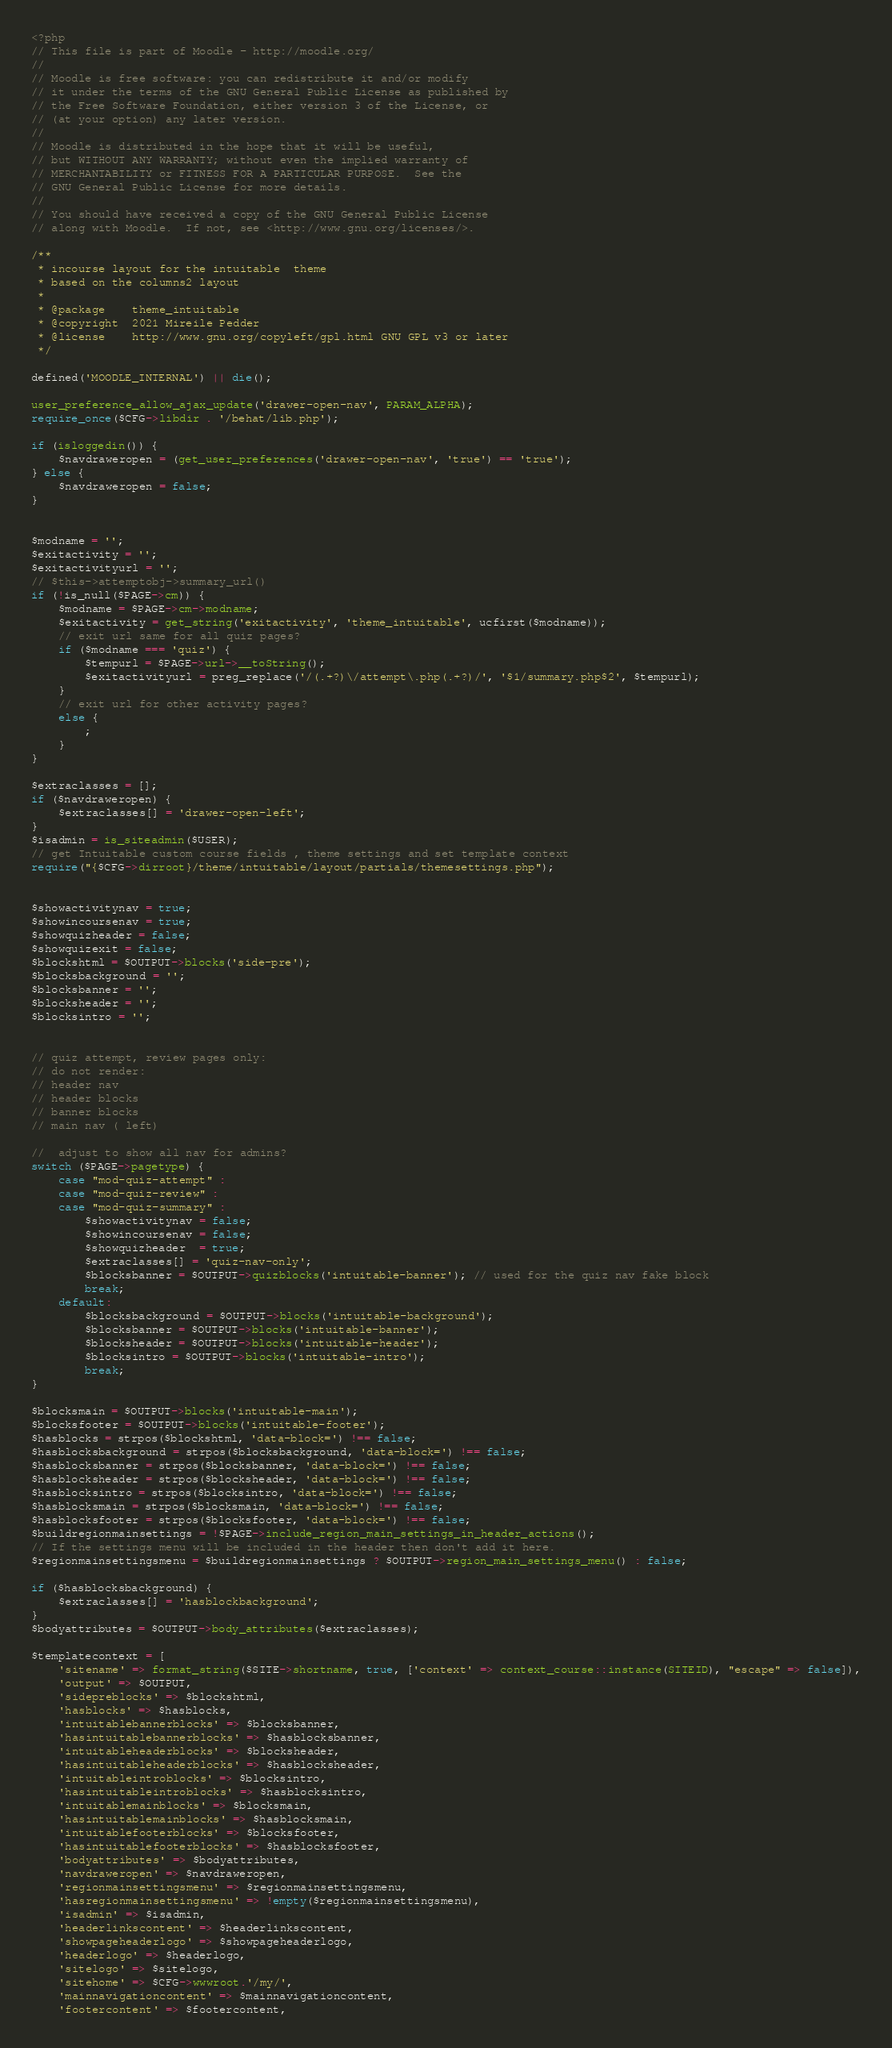Convert code to text. <code><loc_0><loc_0><loc_500><loc_500><_PHP_><?php
// This file is part of Moodle - http://moodle.org/
//
// Moodle is free software: you can redistribute it and/or modify
// it under the terms of the GNU General Public License as published by
// the Free Software Foundation, either version 3 of the License, or
// (at your option) any later version.
//
// Moodle is distributed in the hope that it will be useful,
// but WITHOUT ANY WARRANTY; without even the implied warranty of
// MERCHANTABILITY or FITNESS FOR A PARTICULAR PURPOSE.  See the
// GNU General Public License for more details.
//
// You should have received a copy of the GNU General Public License
// along with Moodle.  If not, see <http://www.gnu.org/licenses/>.

/**
 * incourse layout for the intuitable  theme
 * based on the columns2 layout 
 *
 * @package    theme_intuitable
 * @copyright  2021 Mireile Pedder
 * @license    http://www.gnu.org/copyleft/gpl.html GNU GPL v3 or later
 */

defined('MOODLE_INTERNAL') || die();

user_preference_allow_ajax_update('drawer-open-nav', PARAM_ALPHA);
require_once($CFG->libdir . '/behat/lib.php');

if (isloggedin()) {
    $navdraweropen = (get_user_preferences('drawer-open-nav', 'true') == 'true');
} else {
    $navdraweropen = false;
}


$modname = '';
$exitactivity = '';
$exitactivityurl = '';
// $this->attemptobj->summary_url()
if (!is_null($PAGE->cm)) {
    $modname = $PAGE->cm->modname;
    $exitactivity = get_string('exitactivity', 'theme_intuitable', ucfirst($modname));
    // exit url same for all quiz pages?
    if ($modname === 'quiz') {
        $tempurl = $PAGE->url->__toString();
        $exitactivityurl = preg_replace('/(.+?)\/attempt\.php(.+?)/', '$1/summary.php$2', $tempurl);
    }
    // exit url for other activity pages?
    else {
        ;
    }
}

$extraclasses = [];
if ($navdraweropen) {
    $extraclasses[] = 'drawer-open-left';
}
$isadmin = is_siteadmin($USER);
// get Intuitable custom course fields , theme settings and set template context
require("{$CFG->dirroot}/theme/intuitable/layout/partials/themesettings.php"); 


$showactivitynav = true;
$showincoursenav = true;
$showquizheader = false;
$showquizexit = false;
$blockshtml = $OUTPUT->blocks('side-pre');
$blocksbackground = '';
$blocksbanner = '';
$blocksheader = '';
$blocksintro = '';


// quiz attempt, review pages only:
// do not render:
// header nav
// header blocks
// banner blocks
// main nav ( left)

//  adjust to show all nav for admins?
switch ($PAGE->pagetype) {
    case "mod-quiz-attempt" :
    case "mod-quiz-review" : 
    case "mod-quiz-summary" : 
        $showactivitynav = false;
        $showincoursenav = false;
        $showquizheader  = true;
        $extraclasses[] = 'quiz-nav-only';
        $blocksbanner = $OUTPUT->quizblocks('intuitable-banner'); // used for the quiz nav fake block
        break;
    default: 
        $blocksbackground = $OUTPUT->blocks('intuitable-background');
        $blocksbanner = $OUTPUT->blocks('intuitable-banner');
        $blocksheader = $OUTPUT->blocks('intuitable-header');    
        $blocksintro = $OUTPUT->blocks('intuitable-intro');
        break;
}

$blocksmain = $OUTPUT->blocks('intuitable-main');
$blocksfooter = $OUTPUT->blocks('intuitable-footer');
$hasblocks = strpos($blockshtml, 'data-block=') !== false;
$hasblocksbackground = strpos($blocksbackground, 'data-block=') !== false;
$hasblocksbanner = strpos($blocksbanner, 'data-block=') !== false;
$hasblocksheader = strpos($blocksheader, 'data-block=') !== false;
$hasblocksintro = strpos($blocksintro, 'data-block=') !== false;
$hasblocksmain = strpos($blocksmain, 'data-block=') !== false;
$hasblocksfooter = strpos($blocksfooter, 'data-block=') !== false;
$buildregionmainsettings = !$PAGE->include_region_main_settings_in_header_actions();
// If the settings menu will be included in the header then don't add it here.
$regionmainsettingsmenu = $buildregionmainsettings ? $OUTPUT->region_main_settings_menu() : false;

if ($hasblocksbackground) {
    $extraclasses[] = 'hasblockbackground';
}
$bodyattributes = $OUTPUT->body_attributes($extraclasses);

$templatecontext = [
    'sitename' => format_string($SITE->shortname, true, ['context' => context_course::instance(SITEID), "escape" => false]),
    'output' => $OUTPUT,
    'sidepreblocks' => $blockshtml,
    'hasblocks' => $hasblocks,
    'intuitablebannerblocks' => $blocksbanner,
    'hasintuitablebannerblocks' => $hasblocksbanner,
    'intuitableheaderblocks' => $blocksheader,
    'hasintuitableheaderblocks' => $hasblocksheader,
    'intuitableintroblocks' => $blocksintro,
    'hasintuitableintroblocks' => $hasblocksintro,
    'intuitablemainblocks' => $blocksmain,
    'hasintuitablemainblocks' => $hasblocksmain,
    'intuitablefooterblocks' => $blocksfooter,
    'hasintuitablefooterblocks' => $hasblocksfooter,
    'bodyattributes' => $bodyattributes,
    'navdraweropen' => $navdraweropen,
    'regionmainsettingsmenu' => $regionmainsettingsmenu,
    'hasregionmainsettingsmenu' => !empty($regionmainsettingsmenu),
    'isadmin' => $isadmin,
    'headerlinkscontent' => $headerlinkscontent,
    'showpageheaderlogo' => $showpageheaderlogo,
    'headerlogo' => $headerlogo,
    'sitelogo' => $sitelogo,
    'sitehome' => $CFG->wwwroot.'/my/',
    'mainnavigationcontent' => $mainnavigationcontent,
    'footercontent' => $footercontent,</code> 